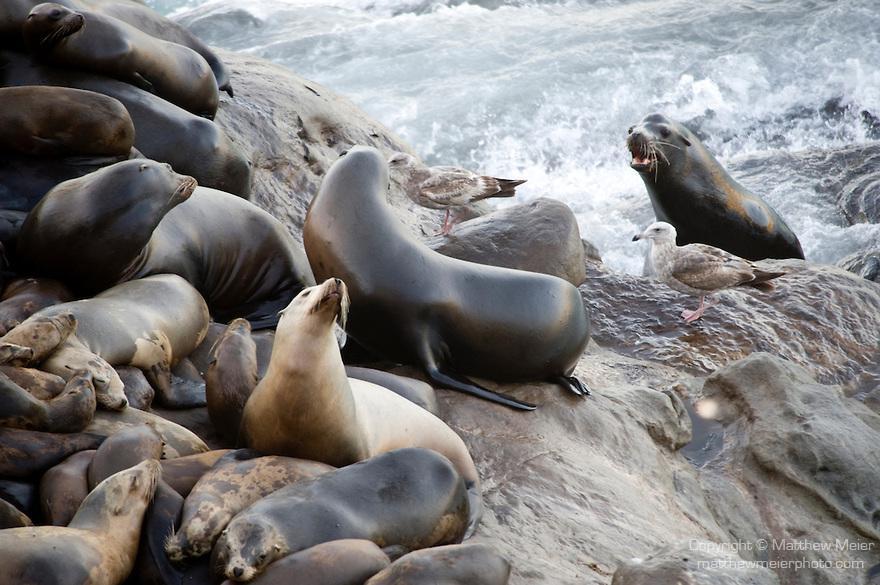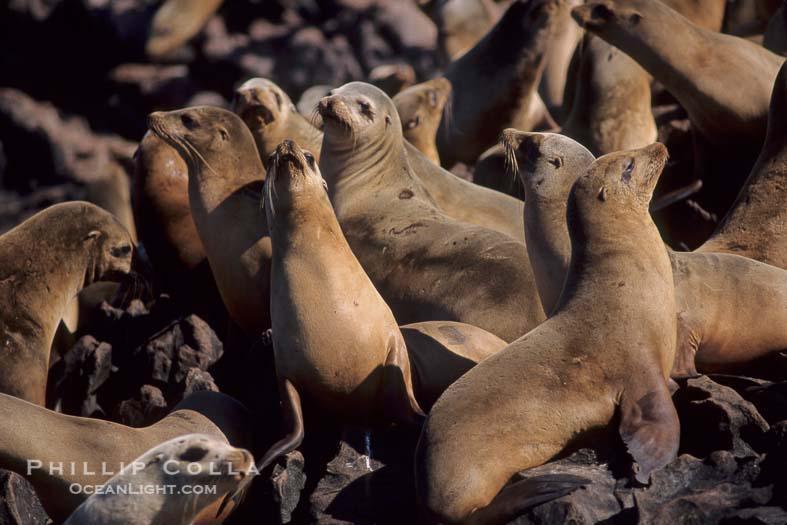The first image is the image on the left, the second image is the image on the right. Evaluate the accuracy of this statement regarding the images: "One image shows white spray from waves crashing where seals are gathered, and the other shows a mass of seals with no ocean background.". Is it true? Answer yes or no. Yes. 